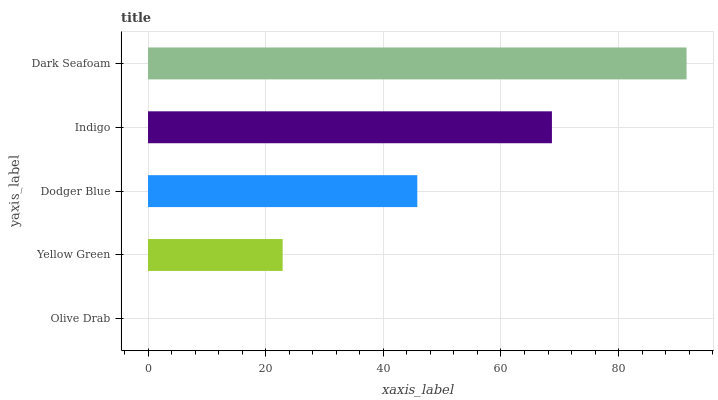Is Olive Drab the minimum?
Answer yes or no. Yes. Is Dark Seafoam the maximum?
Answer yes or no. Yes. Is Yellow Green the minimum?
Answer yes or no. No. Is Yellow Green the maximum?
Answer yes or no. No. Is Yellow Green greater than Olive Drab?
Answer yes or no. Yes. Is Olive Drab less than Yellow Green?
Answer yes or no. Yes. Is Olive Drab greater than Yellow Green?
Answer yes or no. No. Is Yellow Green less than Olive Drab?
Answer yes or no. No. Is Dodger Blue the high median?
Answer yes or no. Yes. Is Dodger Blue the low median?
Answer yes or no. Yes. Is Indigo the high median?
Answer yes or no. No. Is Yellow Green the low median?
Answer yes or no. No. 